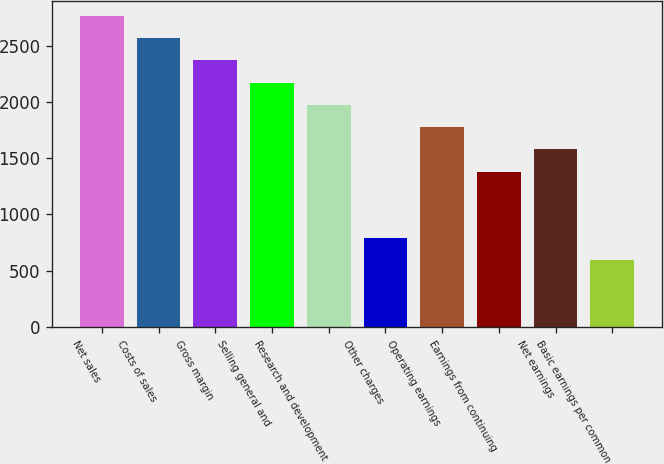<chart> <loc_0><loc_0><loc_500><loc_500><bar_chart><fcel>Net sales<fcel>Costs of sales<fcel>Gross margin<fcel>Selling general and<fcel>Research and development<fcel>Other charges<fcel>Operating earnings<fcel>Earnings from continuing<fcel>Net earnings<fcel>Basic earnings per common<nl><fcel>2762.04<fcel>2564.77<fcel>2367.5<fcel>2170.23<fcel>1972.96<fcel>789.34<fcel>1775.69<fcel>1381.15<fcel>1578.42<fcel>592.07<nl></chart> 